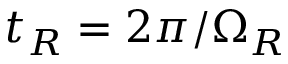Convert formula to latex. <formula><loc_0><loc_0><loc_500><loc_500>t _ { R } = 2 \pi / \Omega _ { R }</formula> 